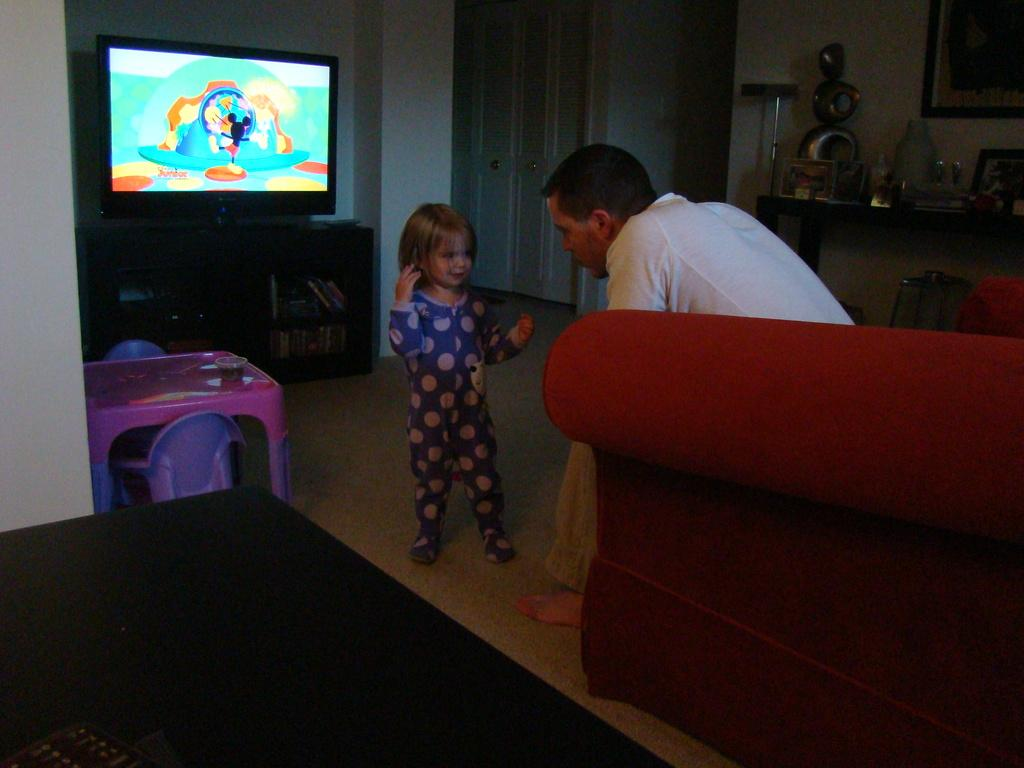Who are the people in the image? There is a girl and a man in the image. What are the man and the girl doing in the image? The man and the girl are sitting on a couch. What is in front of the couch? There is a TV in front of the couch. What else can be seen on the floor in the image? There is a table on the floor in the image. What type of brush is the girl using to paint the ducks in the image? There are no brushes or ducks present in the image; it features a girl and a man sitting on a couch in front of a TV. 